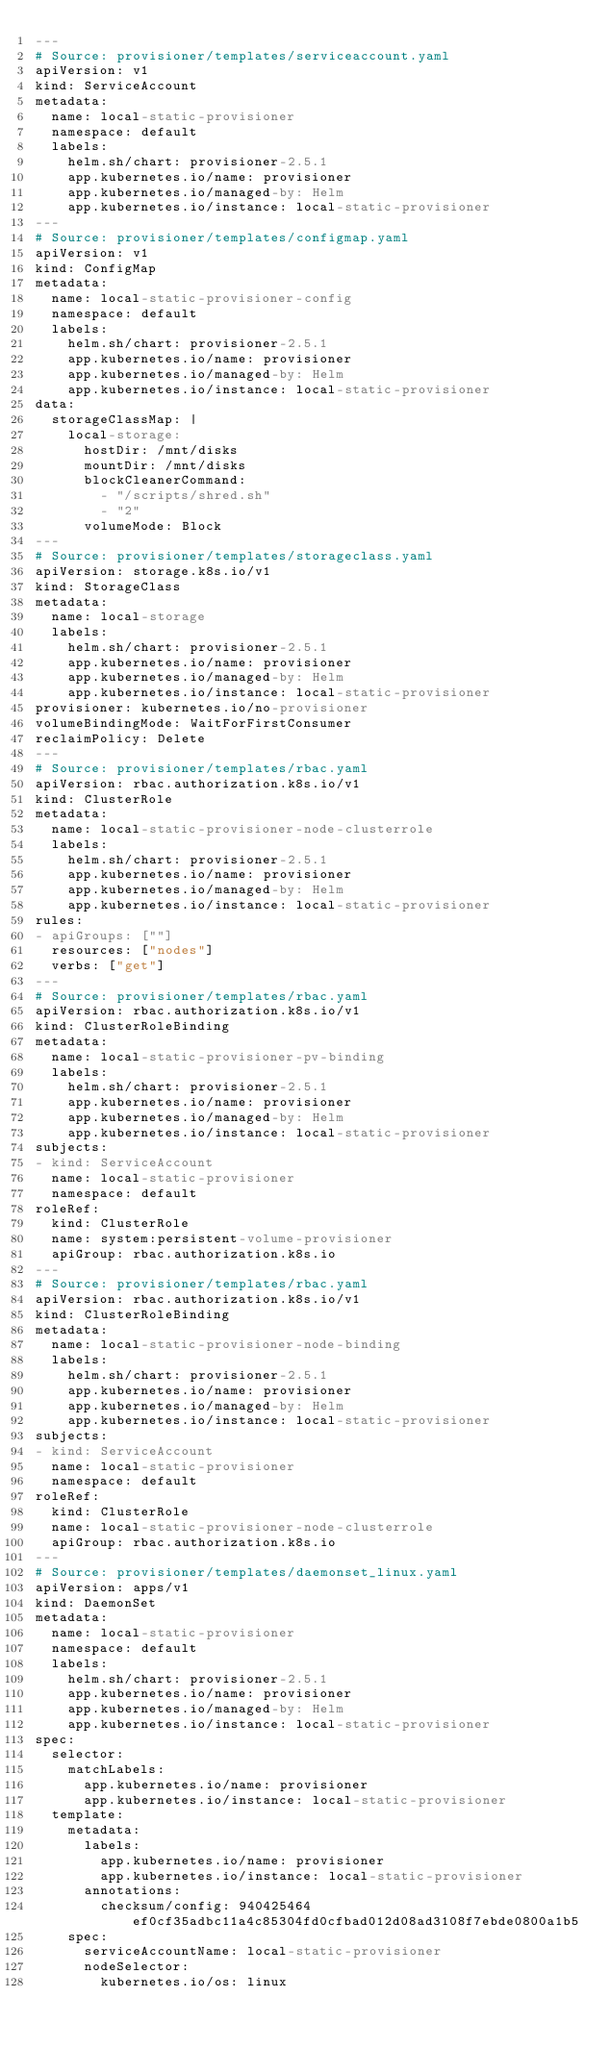Convert code to text. <code><loc_0><loc_0><loc_500><loc_500><_YAML_>---
# Source: provisioner/templates/serviceaccount.yaml
apiVersion: v1
kind: ServiceAccount
metadata:
  name: local-static-provisioner
  namespace: default
  labels:
    helm.sh/chart: provisioner-2.5.1
    app.kubernetes.io/name: provisioner
    app.kubernetes.io/managed-by: Helm
    app.kubernetes.io/instance: local-static-provisioner
---
# Source: provisioner/templates/configmap.yaml
apiVersion: v1
kind: ConfigMap
metadata:
  name: local-static-provisioner-config
  namespace: default
  labels:
    helm.sh/chart: provisioner-2.5.1
    app.kubernetes.io/name: provisioner
    app.kubernetes.io/managed-by: Helm
    app.kubernetes.io/instance: local-static-provisioner
data:
  storageClassMap: |
    local-storage:
      hostDir: /mnt/disks
      mountDir: /mnt/disks
      blockCleanerCommand:
        - "/scripts/shred.sh"
        - "2"
      volumeMode: Block
---
# Source: provisioner/templates/storageclass.yaml
apiVersion: storage.k8s.io/v1
kind: StorageClass
metadata:
  name: local-storage
  labels:
    helm.sh/chart: provisioner-2.5.1
    app.kubernetes.io/name: provisioner
    app.kubernetes.io/managed-by: Helm
    app.kubernetes.io/instance: local-static-provisioner
provisioner: kubernetes.io/no-provisioner
volumeBindingMode: WaitForFirstConsumer
reclaimPolicy: Delete
---
# Source: provisioner/templates/rbac.yaml
apiVersion: rbac.authorization.k8s.io/v1
kind: ClusterRole
metadata:
  name: local-static-provisioner-node-clusterrole
  labels:
    helm.sh/chart: provisioner-2.5.1
    app.kubernetes.io/name: provisioner
    app.kubernetes.io/managed-by: Helm
    app.kubernetes.io/instance: local-static-provisioner
rules:
- apiGroups: [""]
  resources: ["nodes"]
  verbs: ["get"]
---
# Source: provisioner/templates/rbac.yaml
apiVersion: rbac.authorization.k8s.io/v1
kind: ClusterRoleBinding
metadata:
  name: local-static-provisioner-pv-binding
  labels:
    helm.sh/chart: provisioner-2.5.1
    app.kubernetes.io/name: provisioner
    app.kubernetes.io/managed-by: Helm
    app.kubernetes.io/instance: local-static-provisioner
subjects:
- kind: ServiceAccount
  name: local-static-provisioner
  namespace: default
roleRef:
  kind: ClusterRole
  name: system:persistent-volume-provisioner
  apiGroup: rbac.authorization.k8s.io
---
# Source: provisioner/templates/rbac.yaml
apiVersion: rbac.authorization.k8s.io/v1
kind: ClusterRoleBinding
metadata:
  name: local-static-provisioner-node-binding
  labels:
    helm.sh/chart: provisioner-2.5.1
    app.kubernetes.io/name: provisioner
    app.kubernetes.io/managed-by: Helm
    app.kubernetes.io/instance: local-static-provisioner
subjects:
- kind: ServiceAccount
  name: local-static-provisioner
  namespace: default
roleRef:
  kind: ClusterRole
  name: local-static-provisioner-node-clusterrole
  apiGroup: rbac.authorization.k8s.io
---
# Source: provisioner/templates/daemonset_linux.yaml
apiVersion: apps/v1
kind: DaemonSet
metadata:
  name: local-static-provisioner
  namespace: default
  labels:
    helm.sh/chart: provisioner-2.5.1
    app.kubernetes.io/name: provisioner
    app.kubernetes.io/managed-by: Helm
    app.kubernetes.io/instance: local-static-provisioner
spec:
  selector:
    matchLabels:
      app.kubernetes.io/name: provisioner
      app.kubernetes.io/instance: local-static-provisioner
  template:
    metadata:
      labels:
        app.kubernetes.io/name: provisioner
        app.kubernetes.io/instance: local-static-provisioner
      annotations:
        checksum/config: 940425464ef0cf35adbc11a4c85304fd0cfbad012d08ad3108f7ebde0800a1b5
    spec:
      serviceAccountName: local-static-provisioner
      nodeSelector:
        kubernetes.io/os: linux
        </code> 